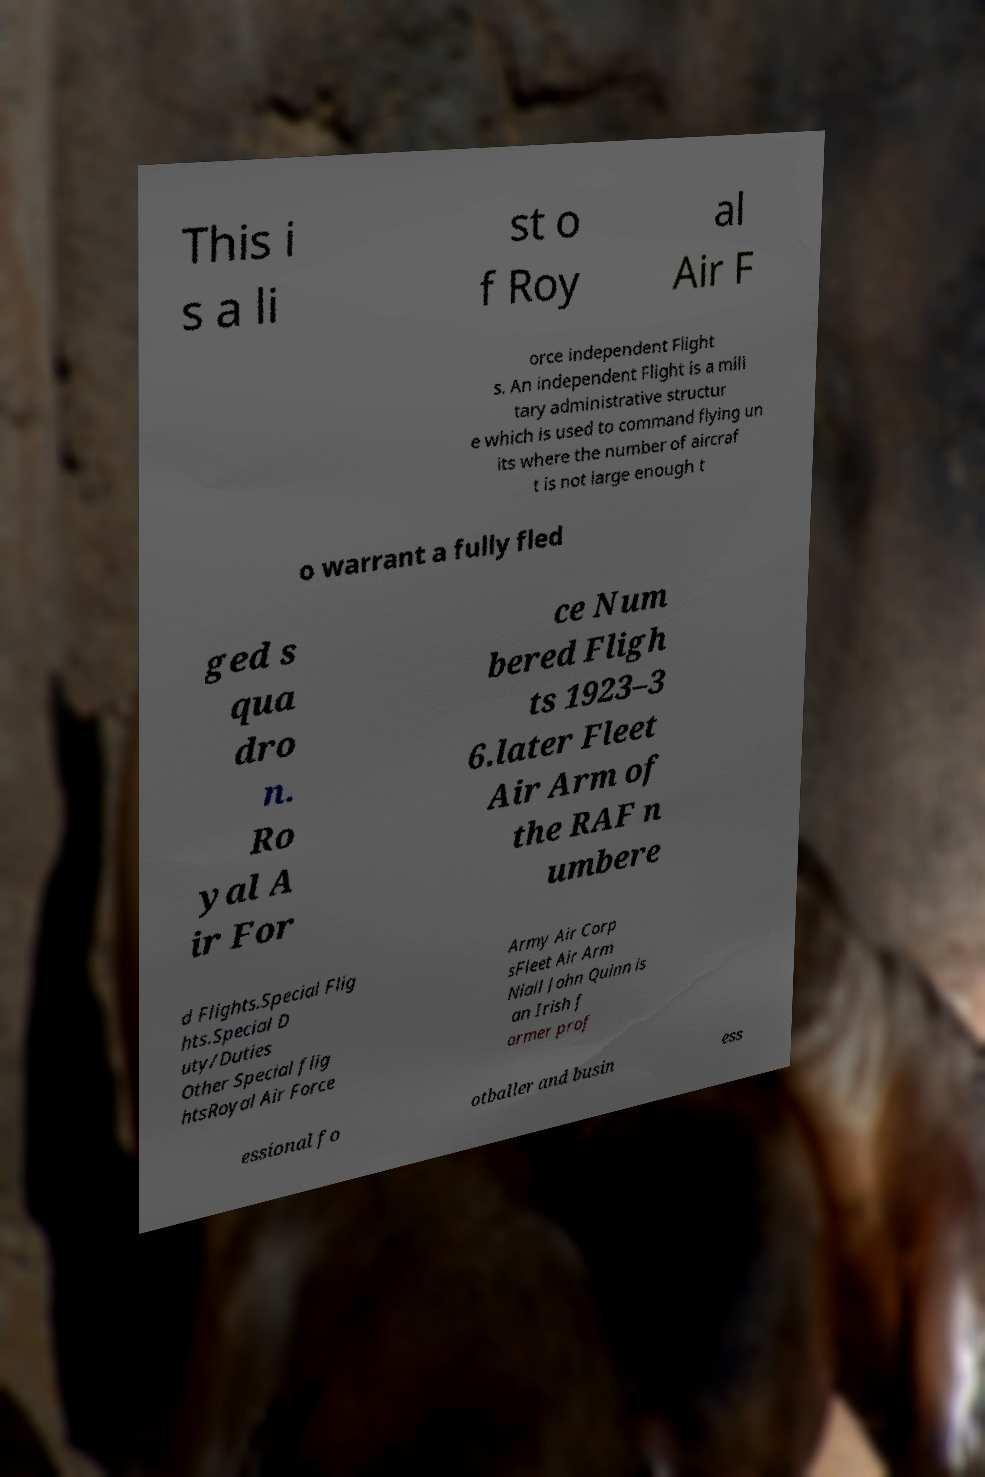Please read and relay the text visible in this image. What does it say? This i s a li st o f Roy al Air F orce independent Flight s. An independent Flight is a mili tary administrative structur e which is used to command flying un its where the number of aircraf t is not large enough t o warrant a fully fled ged s qua dro n. Ro yal A ir For ce Num bered Fligh ts 1923–3 6.later Fleet Air Arm of the RAF n umbere d Flights.Special Flig hts.Special D uty/Duties Other Special flig htsRoyal Air Force Army Air Corp sFleet Air Arm Niall John Quinn is an Irish f ormer prof essional fo otballer and busin ess 